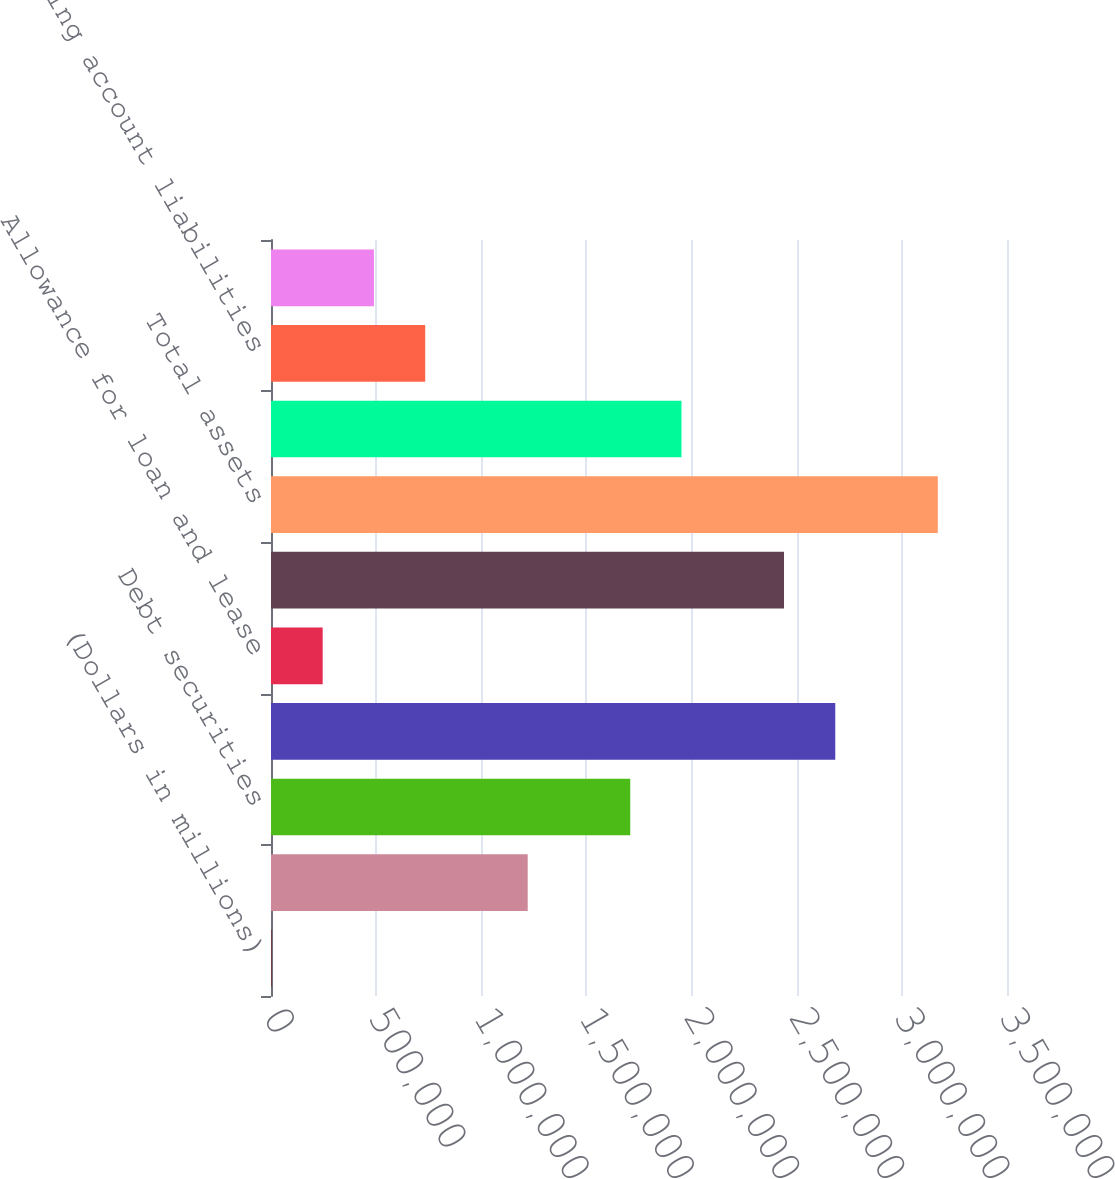Convert chart. <chart><loc_0><loc_0><loc_500><loc_500><bar_chart><fcel>(Dollars in millions)<fcel>Trading account assets<fcel>Debt securities<fcel>Loans and leases<fcel>Allowance for loan and lease<fcel>All other assets<fcel>Total assets<fcel>Federal funds purchased and<fcel>Trading account liabilities<fcel>Commercial paper and other<nl><fcel>2010<fcel>1.22081e+06<fcel>1.70832e+06<fcel>2.68336e+06<fcel>245769<fcel>2.4396e+06<fcel>3.17088e+06<fcel>1.95208e+06<fcel>733288<fcel>489528<nl></chart> 